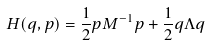Convert formula to latex. <formula><loc_0><loc_0><loc_500><loc_500>H ( q , p ) = \frac { 1 } { 2 } p M ^ { - 1 } p + \frac { 1 } { 2 } q \Lambda q</formula> 